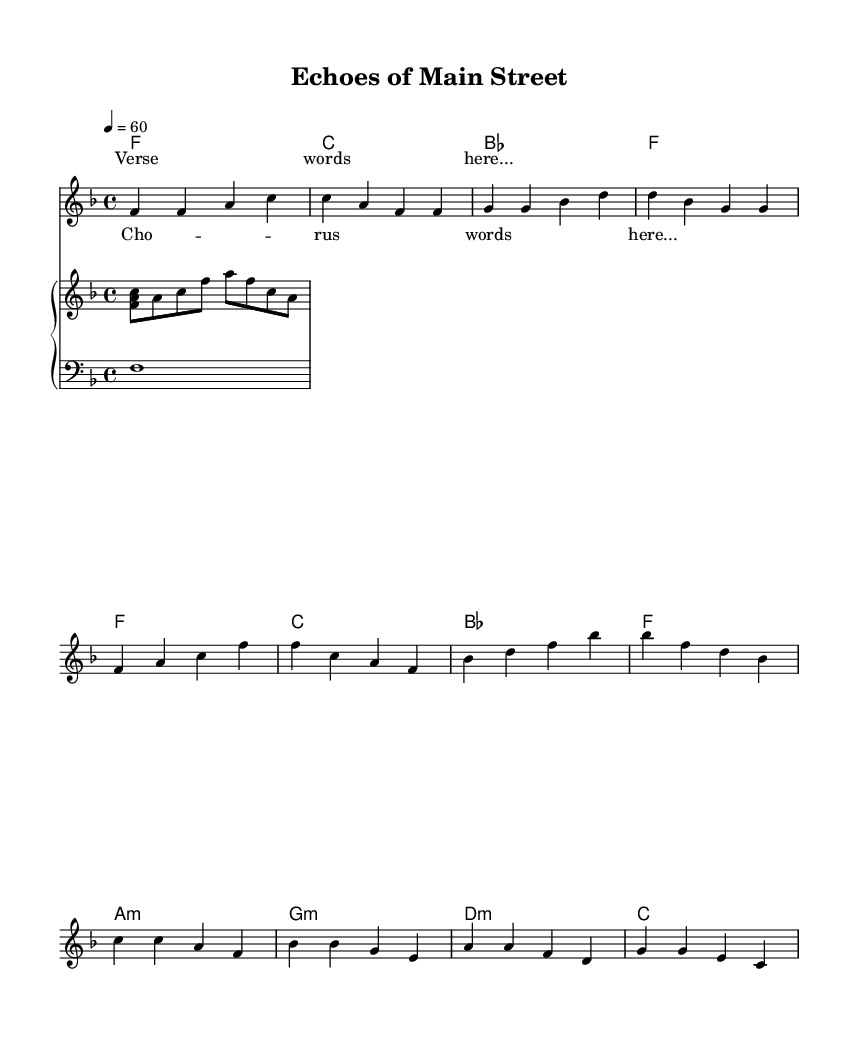What is the key signature of this music? The key signature of the music is F major, which has one flat (B flat). This can be observed at the beginning of the music where the key signature is indicated.
Answer: F major What is the time signature of this music? The time signature is 4/4, as shown at the start of the piece. In 4/4 time, there are four beats in each measure, and the quarter note gets one beat.
Answer: 4/4 What is the tempo marking of this song? The tempo marking in the music is set at quarter note equals 60 beats per minute, which indicates a moderate pace for the piece. This is indicated in the tempo instructions at the beginning of the sheet music.
Answer: 60 How many measures are in the verse section? The verse section consists of four measures, which can be counted directly from the melody block containing the verse notes. Each group of four beats corresponds to one measure.
Answer: 4 What type of chords are primarily used in the bridge section? The chords used in the bridge are minor chords: A minor, G minor, and D minor. Although the bridge features G major and C major, the emphasis is on the minor chords, which contributes to the soulful feel typical of Rhythm and Blues.
Answer: Minor How does the phrase structure of this piece resemble a traditional soul ballad? The phrase structure includes a distinct verse, chorus, and bridge. This ABA format is characteristic of soul ballads, where the emotional delivery in the verse leads into the memorable and powerful chorus, followed by a contrasting bridge.
Answer: AABA 